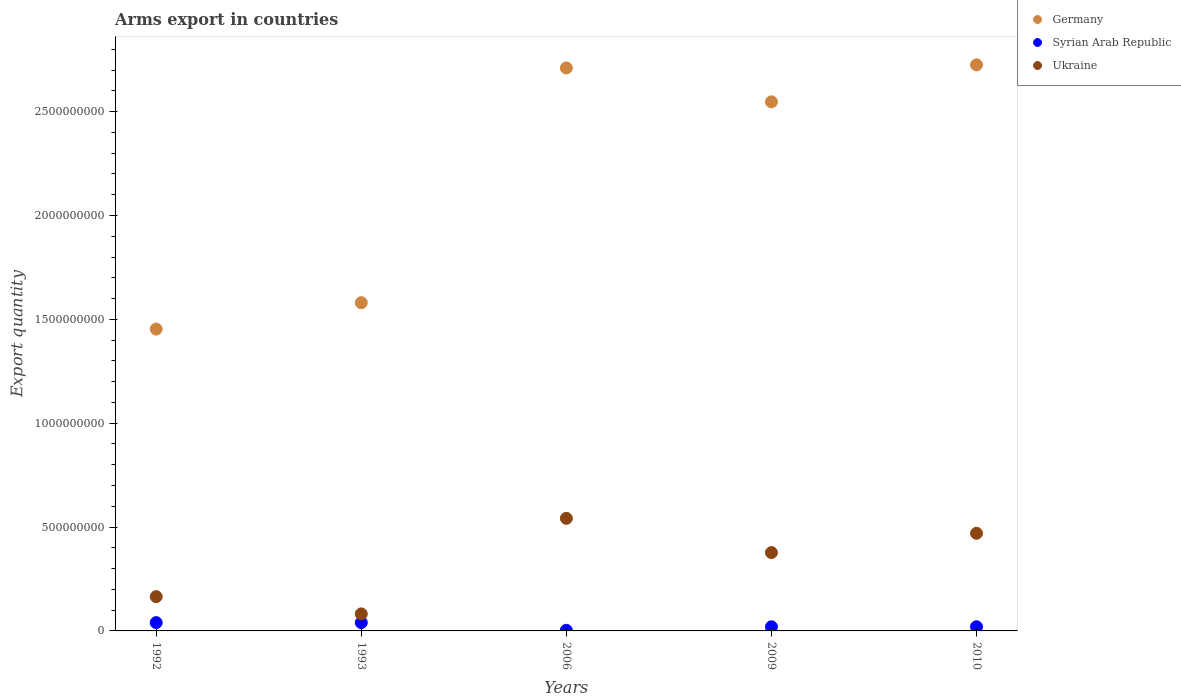Across all years, what is the maximum total arms export in Ukraine?
Ensure brevity in your answer.  5.42e+08. Across all years, what is the minimum total arms export in Syrian Arab Republic?
Offer a terse response. 3.00e+06. In which year was the total arms export in Germany maximum?
Give a very brief answer. 2010. What is the total total arms export in Germany in the graph?
Keep it short and to the point. 1.10e+1. What is the difference between the total arms export in Ukraine in 1993 and the total arms export in Germany in 2010?
Provide a succinct answer. -2.64e+09. What is the average total arms export in Ukraine per year?
Ensure brevity in your answer.  3.27e+08. In the year 1993, what is the difference between the total arms export in Germany and total arms export in Syrian Arab Republic?
Ensure brevity in your answer.  1.54e+09. What is the ratio of the total arms export in Syrian Arab Republic in 1993 to that in 2009?
Provide a short and direct response. 2. What is the difference between the highest and the second highest total arms export in Germany?
Give a very brief answer. 1.50e+07. What is the difference between the highest and the lowest total arms export in Ukraine?
Keep it short and to the point. 4.60e+08. In how many years, is the total arms export in Syrian Arab Republic greater than the average total arms export in Syrian Arab Republic taken over all years?
Provide a succinct answer. 2. Is the sum of the total arms export in Ukraine in 1993 and 2010 greater than the maximum total arms export in Germany across all years?
Your answer should be compact. No. Is it the case that in every year, the sum of the total arms export in Ukraine and total arms export in Germany  is greater than the total arms export in Syrian Arab Republic?
Offer a terse response. Yes. Does the total arms export in Germany monotonically increase over the years?
Offer a terse response. No. How many dotlines are there?
Provide a short and direct response. 3. How many years are there in the graph?
Make the answer very short. 5. What is the difference between two consecutive major ticks on the Y-axis?
Provide a succinct answer. 5.00e+08. Are the values on the major ticks of Y-axis written in scientific E-notation?
Give a very brief answer. No. Does the graph contain any zero values?
Offer a terse response. No. How are the legend labels stacked?
Ensure brevity in your answer.  Vertical. What is the title of the graph?
Give a very brief answer. Arms export in countries. What is the label or title of the X-axis?
Your answer should be compact. Years. What is the label or title of the Y-axis?
Provide a short and direct response. Export quantity. What is the Export quantity in Germany in 1992?
Provide a short and direct response. 1.45e+09. What is the Export quantity of Syrian Arab Republic in 1992?
Give a very brief answer. 4.00e+07. What is the Export quantity in Ukraine in 1992?
Provide a succinct answer. 1.65e+08. What is the Export quantity in Germany in 1993?
Keep it short and to the point. 1.58e+09. What is the Export quantity in Syrian Arab Republic in 1993?
Offer a terse response. 4.00e+07. What is the Export quantity of Ukraine in 1993?
Give a very brief answer. 8.20e+07. What is the Export quantity of Germany in 2006?
Keep it short and to the point. 2.71e+09. What is the Export quantity in Syrian Arab Republic in 2006?
Provide a short and direct response. 3.00e+06. What is the Export quantity in Ukraine in 2006?
Offer a terse response. 5.42e+08. What is the Export quantity in Germany in 2009?
Give a very brief answer. 2.55e+09. What is the Export quantity in Ukraine in 2009?
Offer a terse response. 3.77e+08. What is the Export quantity in Germany in 2010?
Provide a short and direct response. 2.72e+09. What is the Export quantity of Syrian Arab Republic in 2010?
Provide a short and direct response. 2.00e+07. What is the Export quantity in Ukraine in 2010?
Offer a very short reply. 4.70e+08. Across all years, what is the maximum Export quantity of Germany?
Ensure brevity in your answer.  2.72e+09. Across all years, what is the maximum Export quantity in Syrian Arab Republic?
Make the answer very short. 4.00e+07. Across all years, what is the maximum Export quantity in Ukraine?
Offer a terse response. 5.42e+08. Across all years, what is the minimum Export quantity of Germany?
Keep it short and to the point. 1.45e+09. Across all years, what is the minimum Export quantity of Syrian Arab Republic?
Offer a very short reply. 3.00e+06. Across all years, what is the minimum Export quantity in Ukraine?
Offer a terse response. 8.20e+07. What is the total Export quantity in Germany in the graph?
Offer a terse response. 1.10e+1. What is the total Export quantity of Syrian Arab Republic in the graph?
Offer a very short reply. 1.23e+08. What is the total Export quantity in Ukraine in the graph?
Your answer should be compact. 1.64e+09. What is the difference between the Export quantity in Germany in 1992 and that in 1993?
Offer a very short reply. -1.27e+08. What is the difference between the Export quantity of Syrian Arab Republic in 1992 and that in 1993?
Offer a terse response. 0. What is the difference between the Export quantity in Ukraine in 1992 and that in 1993?
Provide a succinct answer. 8.30e+07. What is the difference between the Export quantity in Germany in 1992 and that in 2006?
Offer a very short reply. -1.26e+09. What is the difference between the Export quantity in Syrian Arab Republic in 1992 and that in 2006?
Give a very brief answer. 3.70e+07. What is the difference between the Export quantity of Ukraine in 1992 and that in 2006?
Your response must be concise. -3.77e+08. What is the difference between the Export quantity in Germany in 1992 and that in 2009?
Give a very brief answer. -1.09e+09. What is the difference between the Export quantity of Syrian Arab Republic in 1992 and that in 2009?
Your answer should be very brief. 2.00e+07. What is the difference between the Export quantity in Ukraine in 1992 and that in 2009?
Offer a terse response. -2.12e+08. What is the difference between the Export quantity of Germany in 1992 and that in 2010?
Keep it short and to the point. -1.27e+09. What is the difference between the Export quantity in Ukraine in 1992 and that in 2010?
Give a very brief answer. -3.05e+08. What is the difference between the Export quantity of Germany in 1993 and that in 2006?
Give a very brief answer. -1.13e+09. What is the difference between the Export quantity of Syrian Arab Republic in 1993 and that in 2006?
Offer a terse response. 3.70e+07. What is the difference between the Export quantity of Ukraine in 1993 and that in 2006?
Ensure brevity in your answer.  -4.60e+08. What is the difference between the Export quantity in Germany in 1993 and that in 2009?
Ensure brevity in your answer.  -9.67e+08. What is the difference between the Export quantity of Syrian Arab Republic in 1993 and that in 2009?
Provide a short and direct response. 2.00e+07. What is the difference between the Export quantity of Ukraine in 1993 and that in 2009?
Provide a succinct answer. -2.95e+08. What is the difference between the Export quantity of Germany in 1993 and that in 2010?
Ensure brevity in your answer.  -1.14e+09. What is the difference between the Export quantity of Ukraine in 1993 and that in 2010?
Make the answer very short. -3.88e+08. What is the difference between the Export quantity of Germany in 2006 and that in 2009?
Give a very brief answer. 1.63e+08. What is the difference between the Export quantity of Syrian Arab Republic in 2006 and that in 2009?
Keep it short and to the point. -1.70e+07. What is the difference between the Export quantity in Ukraine in 2006 and that in 2009?
Provide a succinct answer. 1.65e+08. What is the difference between the Export quantity in Germany in 2006 and that in 2010?
Give a very brief answer. -1.50e+07. What is the difference between the Export quantity of Syrian Arab Republic in 2006 and that in 2010?
Keep it short and to the point. -1.70e+07. What is the difference between the Export quantity in Ukraine in 2006 and that in 2010?
Offer a very short reply. 7.20e+07. What is the difference between the Export quantity in Germany in 2009 and that in 2010?
Provide a short and direct response. -1.78e+08. What is the difference between the Export quantity in Syrian Arab Republic in 2009 and that in 2010?
Your answer should be very brief. 0. What is the difference between the Export quantity of Ukraine in 2009 and that in 2010?
Give a very brief answer. -9.30e+07. What is the difference between the Export quantity in Germany in 1992 and the Export quantity in Syrian Arab Republic in 1993?
Offer a very short reply. 1.41e+09. What is the difference between the Export quantity of Germany in 1992 and the Export quantity of Ukraine in 1993?
Your answer should be very brief. 1.37e+09. What is the difference between the Export quantity of Syrian Arab Republic in 1992 and the Export quantity of Ukraine in 1993?
Give a very brief answer. -4.20e+07. What is the difference between the Export quantity of Germany in 1992 and the Export quantity of Syrian Arab Republic in 2006?
Provide a succinct answer. 1.45e+09. What is the difference between the Export quantity in Germany in 1992 and the Export quantity in Ukraine in 2006?
Keep it short and to the point. 9.11e+08. What is the difference between the Export quantity of Syrian Arab Republic in 1992 and the Export quantity of Ukraine in 2006?
Offer a very short reply. -5.02e+08. What is the difference between the Export quantity of Germany in 1992 and the Export quantity of Syrian Arab Republic in 2009?
Provide a succinct answer. 1.43e+09. What is the difference between the Export quantity of Germany in 1992 and the Export quantity of Ukraine in 2009?
Give a very brief answer. 1.08e+09. What is the difference between the Export quantity in Syrian Arab Republic in 1992 and the Export quantity in Ukraine in 2009?
Your answer should be compact. -3.37e+08. What is the difference between the Export quantity of Germany in 1992 and the Export quantity of Syrian Arab Republic in 2010?
Offer a very short reply. 1.43e+09. What is the difference between the Export quantity of Germany in 1992 and the Export quantity of Ukraine in 2010?
Keep it short and to the point. 9.83e+08. What is the difference between the Export quantity in Syrian Arab Republic in 1992 and the Export quantity in Ukraine in 2010?
Your response must be concise. -4.30e+08. What is the difference between the Export quantity in Germany in 1993 and the Export quantity in Syrian Arab Republic in 2006?
Provide a short and direct response. 1.58e+09. What is the difference between the Export quantity of Germany in 1993 and the Export quantity of Ukraine in 2006?
Your response must be concise. 1.04e+09. What is the difference between the Export quantity in Syrian Arab Republic in 1993 and the Export quantity in Ukraine in 2006?
Your response must be concise. -5.02e+08. What is the difference between the Export quantity of Germany in 1993 and the Export quantity of Syrian Arab Republic in 2009?
Make the answer very short. 1.56e+09. What is the difference between the Export quantity of Germany in 1993 and the Export quantity of Ukraine in 2009?
Provide a succinct answer. 1.20e+09. What is the difference between the Export quantity in Syrian Arab Republic in 1993 and the Export quantity in Ukraine in 2009?
Offer a very short reply. -3.37e+08. What is the difference between the Export quantity in Germany in 1993 and the Export quantity in Syrian Arab Republic in 2010?
Ensure brevity in your answer.  1.56e+09. What is the difference between the Export quantity in Germany in 1993 and the Export quantity in Ukraine in 2010?
Your answer should be compact. 1.11e+09. What is the difference between the Export quantity of Syrian Arab Republic in 1993 and the Export quantity of Ukraine in 2010?
Give a very brief answer. -4.30e+08. What is the difference between the Export quantity of Germany in 2006 and the Export quantity of Syrian Arab Republic in 2009?
Offer a terse response. 2.69e+09. What is the difference between the Export quantity in Germany in 2006 and the Export quantity in Ukraine in 2009?
Provide a succinct answer. 2.33e+09. What is the difference between the Export quantity in Syrian Arab Republic in 2006 and the Export quantity in Ukraine in 2009?
Your response must be concise. -3.74e+08. What is the difference between the Export quantity in Germany in 2006 and the Export quantity in Syrian Arab Republic in 2010?
Your response must be concise. 2.69e+09. What is the difference between the Export quantity in Germany in 2006 and the Export quantity in Ukraine in 2010?
Provide a succinct answer. 2.24e+09. What is the difference between the Export quantity of Syrian Arab Republic in 2006 and the Export quantity of Ukraine in 2010?
Your response must be concise. -4.67e+08. What is the difference between the Export quantity in Germany in 2009 and the Export quantity in Syrian Arab Republic in 2010?
Give a very brief answer. 2.53e+09. What is the difference between the Export quantity of Germany in 2009 and the Export quantity of Ukraine in 2010?
Provide a short and direct response. 2.08e+09. What is the difference between the Export quantity of Syrian Arab Republic in 2009 and the Export quantity of Ukraine in 2010?
Make the answer very short. -4.50e+08. What is the average Export quantity of Germany per year?
Give a very brief answer. 2.20e+09. What is the average Export quantity of Syrian Arab Republic per year?
Your answer should be compact. 2.46e+07. What is the average Export quantity in Ukraine per year?
Provide a short and direct response. 3.27e+08. In the year 1992, what is the difference between the Export quantity of Germany and Export quantity of Syrian Arab Republic?
Give a very brief answer. 1.41e+09. In the year 1992, what is the difference between the Export quantity in Germany and Export quantity in Ukraine?
Offer a very short reply. 1.29e+09. In the year 1992, what is the difference between the Export quantity of Syrian Arab Republic and Export quantity of Ukraine?
Give a very brief answer. -1.25e+08. In the year 1993, what is the difference between the Export quantity in Germany and Export quantity in Syrian Arab Republic?
Give a very brief answer. 1.54e+09. In the year 1993, what is the difference between the Export quantity in Germany and Export quantity in Ukraine?
Give a very brief answer. 1.50e+09. In the year 1993, what is the difference between the Export quantity of Syrian Arab Republic and Export quantity of Ukraine?
Provide a succinct answer. -4.20e+07. In the year 2006, what is the difference between the Export quantity in Germany and Export quantity in Syrian Arab Republic?
Provide a succinct answer. 2.71e+09. In the year 2006, what is the difference between the Export quantity in Germany and Export quantity in Ukraine?
Your response must be concise. 2.17e+09. In the year 2006, what is the difference between the Export quantity in Syrian Arab Republic and Export quantity in Ukraine?
Keep it short and to the point. -5.39e+08. In the year 2009, what is the difference between the Export quantity in Germany and Export quantity in Syrian Arab Republic?
Provide a succinct answer. 2.53e+09. In the year 2009, what is the difference between the Export quantity of Germany and Export quantity of Ukraine?
Provide a short and direct response. 2.17e+09. In the year 2009, what is the difference between the Export quantity in Syrian Arab Republic and Export quantity in Ukraine?
Provide a succinct answer. -3.57e+08. In the year 2010, what is the difference between the Export quantity in Germany and Export quantity in Syrian Arab Republic?
Provide a succinct answer. 2.70e+09. In the year 2010, what is the difference between the Export quantity in Germany and Export quantity in Ukraine?
Provide a succinct answer. 2.26e+09. In the year 2010, what is the difference between the Export quantity of Syrian Arab Republic and Export quantity of Ukraine?
Keep it short and to the point. -4.50e+08. What is the ratio of the Export quantity of Germany in 1992 to that in 1993?
Give a very brief answer. 0.92. What is the ratio of the Export quantity in Syrian Arab Republic in 1992 to that in 1993?
Provide a short and direct response. 1. What is the ratio of the Export quantity of Ukraine in 1992 to that in 1993?
Your answer should be compact. 2.01. What is the ratio of the Export quantity in Germany in 1992 to that in 2006?
Make the answer very short. 0.54. What is the ratio of the Export quantity of Syrian Arab Republic in 1992 to that in 2006?
Make the answer very short. 13.33. What is the ratio of the Export quantity in Ukraine in 1992 to that in 2006?
Your answer should be compact. 0.3. What is the ratio of the Export quantity in Germany in 1992 to that in 2009?
Ensure brevity in your answer.  0.57. What is the ratio of the Export quantity in Syrian Arab Republic in 1992 to that in 2009?
Your response must be concise. 2. What is the ratio of the Export quantity in Ukraine in 1992 to that in 2009?
Provide a succinct answer. 0.44. What is the ratio of the Export quantity in Germany in 1992 to that in 2010?
Give a very brief answer. 0.53. What is the ratio of the Export quantity of Syrian Arab Republic in 1992 to that in 2010?
Your answer should be very brief. 2. What is the ratio of the Export quantity in Ukraine in 1992 to that in 2010?
Make the answer very short. 0.35. What is the ratio of the Export quantity of Germany in 1993 to that in 2006?
Provide a succinct answer. 0.58. What is the ratio of the Export quantity of Syrian Arab Republic in 1993 to that in 2006?
Offer a terse response. 13.33. What is the ratio of the Export quantity of Ukraine in 1993 to that in 2006?
Give a very brief answer. 0.15. What is the ratio of the Export quantity in Germany in 1993 to that in 2009?
Provide a succinct answer. 0.62. What is the ratio of the Export quantity of Syrian Arab Republic in 1993 to that in 2009?
Ensure brevity in your answer.  2. What is the ratio of the Export quantity of Ukraine in 1993 to that in 2009?
Provide a succinct answer. 0.22. What is the ratio of the Export quantity of Germany in 1993 to that in 2010?
Your answer should be compact. 0.58. What is the ratio of the Export quantity of Ukraine in 1993 to that in 2010?
Make the answer very short. 0.17. What is the ratio of the Export quantity of Germany in 2006 to that in 2009?
Keep it short and to the point. 1.06. What is the ratio of the Export quantity of Syrian Arab Republic in 2006 to that in 2009?
Ensure brevity in your answer.  0.15. What is the ratio of the Export quantity of Ukraine in 2006 to that in 2009?
Offer a terse response. 1.44. What is the ratio of the Export quantity of Germany in 2006 to that in 2010?
Give a very brief answer. 0.99. What is the ratio of the Export quantity of Ukraine in 2006 to that in 2010?
Offer a very short reply. 1.15. What is the ratio of the Export quantity of Germany in 2009 to that in 2010?
Provide a succinct answer. 0.93. What is the ratio of the Export quantity in Syrian Arab Republic in 2009 to that in 2010?
Ensure brevity in your answer.  1. What is the ratio of the Export quantity in Ukraine in 2009 to that in 2010?
Your answer should be very brief. 0.8. What is the difference between the highest and the second highest Export quantity in Germany?
Provide a short and direct response. 1.50e+07. What is the difference between the highest and the second highest Export quantity in Ukraine?
Offer a very short reply. 7.20e+07. What is the difference between the highest and the lowest Export quantity of Germany?
Your response must be concise. 1.27e+09. What is the difference between the highest and the lowest Export quantity of Syrian Arab Republic?
Provide a short and direct response. 3.70e+07. What is the difference between the highest and the lowest Export quantity of Ukraine?
Make the answer very short. 4.60e+08. 